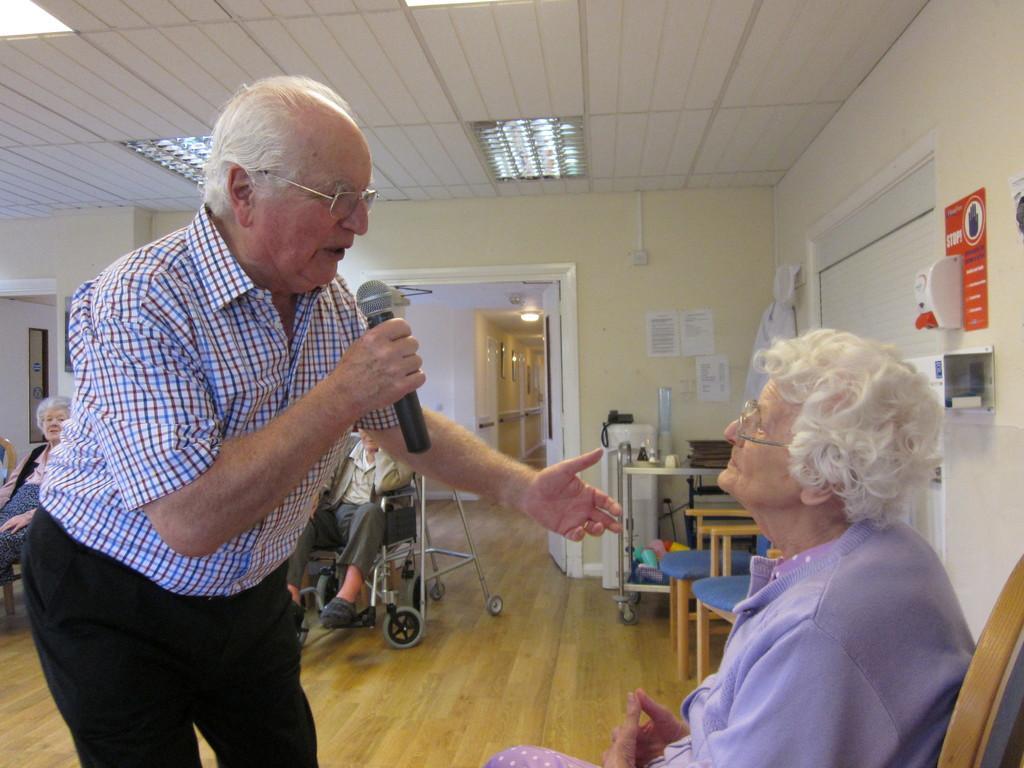Could you give a brief overview of what you see in this image? This picture is clicked inside the room. On the right we can see a person sitting on the chair. On the left there is a man holding a microphone, wearing shirt, standing and seems to be talking. At the top there is a roof. In the background we can see the wall, light, doors, text on the posters which are attached to the wall and we can see the chairs, table containing some objects and we can see a telephone placed on the top of an object and we can see a person sitting on the wheelchair and we can see a person seems to be sitting on the chair and we can see many other objects in the background. 